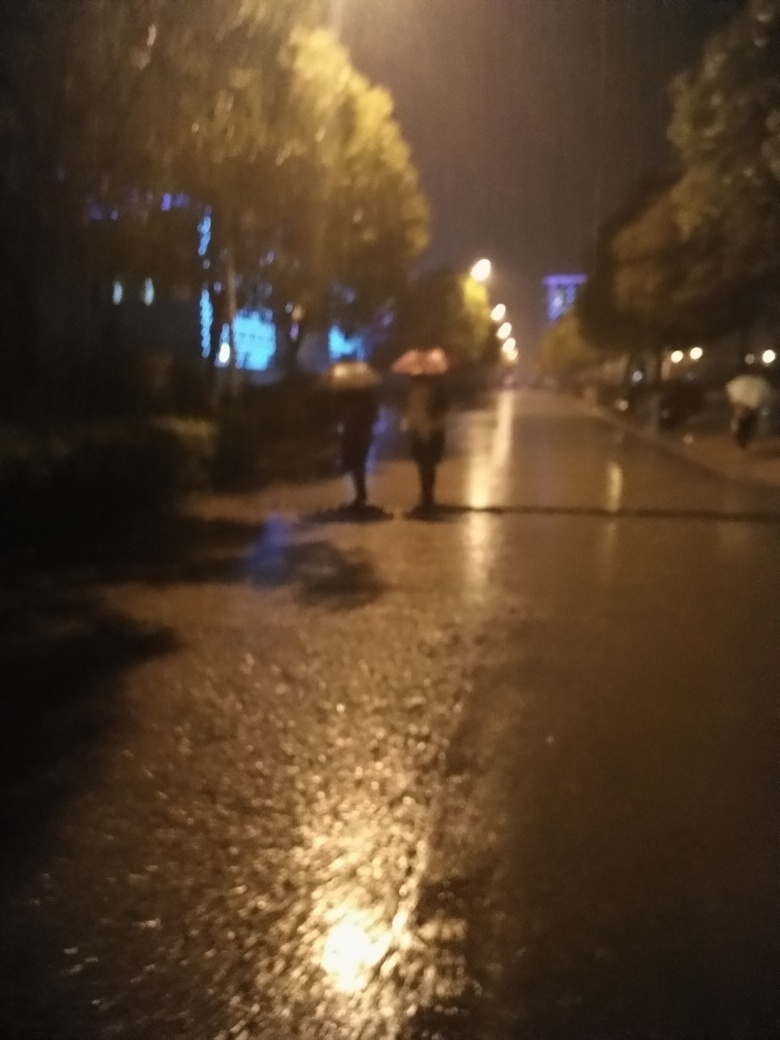What feelings does this image evoke? The image may evoke feelings of solitude or pensiveness due to the dim lighting and rainy atmosphere. There is a sense of stillness in the scene, contrasted by the movement of individuals who are likely trying to find shelter. It might also stir a feeling of coziness or contemplation as one imagines the quiet of the evening after the rain. 